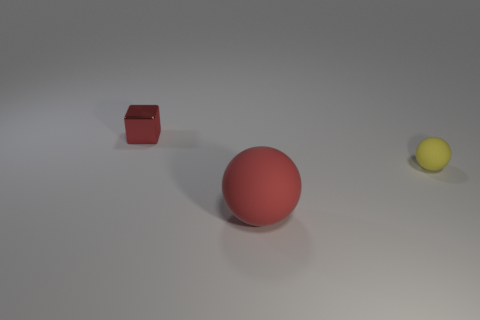How many purple balls are there?
Provide a short and direct response. 0. What number of objects are the same material as the tiny block?
Your response must be concise. 0. Are there the same number of large red rubber spheres that are left of the small red metal object and tiny yellow objects?
Give a very brief answer. No. There is a tiny block that is the same color as the big matte sphere; what is it made of?
Your answer should be very brief. Metal. There is a metal cube; is it the same size as the thing right of the big red thing?
Keep it short and to the point. Yes. How many other things are there of the same size as the yellow matte thing?
Provide a succinct answer. 1. What number of other things are there of the same color as the tiny block?
Your answer should be compact. 1. Is there anything else that is the same size as the yellow sphere?
Offer a very short reply. Yes. What number of other things are the same shape as the small yellow thing?
Keep it short and to the point. 1. Do the red shiny block and the red matte thing have the same size?
Provide a short and direct response. No. 